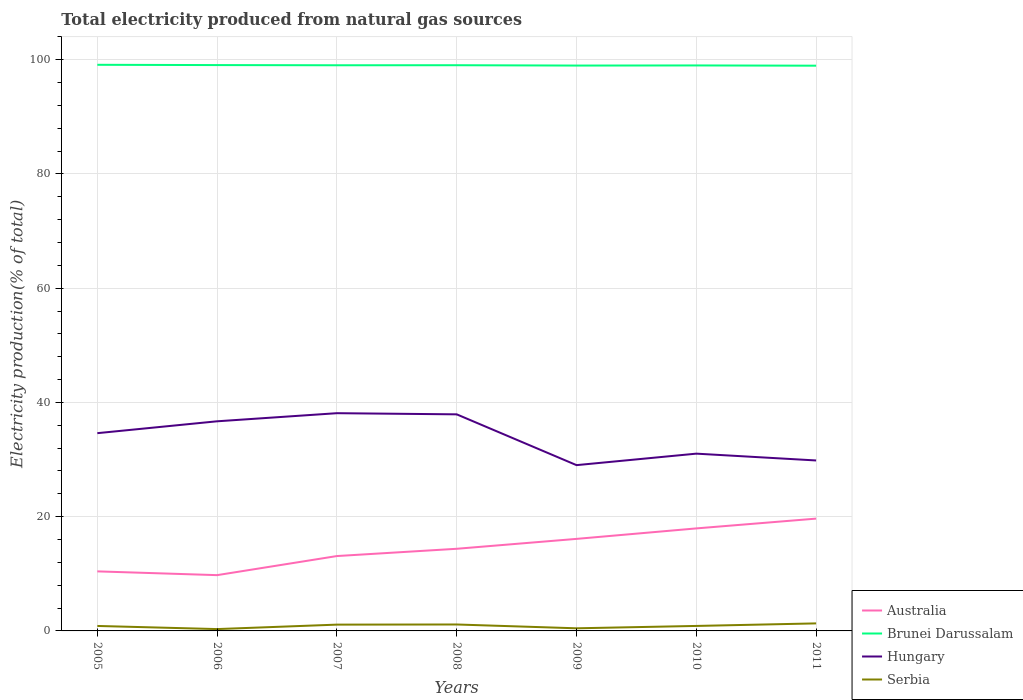How many different coloured lines are there?
Give a very brief answer. 4. Does the line corresponding to Hungary intersect with the line corresponding to Serbia?
Your answer should be very brief. No. Across all years, what is the maximum total electricity produced in Australia?
Give a very brief answer. 9.77. In which year was the total electricity produced in Serbia maximum?
Keep it short and to the point. 2006. What is the total total electricity produced in Serbia in the graph?
Give a very brief answer. -0. What is the difference between the highest and the second highest total electricity produced in Australia?
Keep it short and to the point. 9.9. How many years are there in the graph?
Offer a very short reply. 7. Are the values on the major ticks of Y-axis written in scientific E-notation?
Make the answer very short. No. Does the graph contain grids?
Keep it short and to the point. Yes. What is the title of the graph?
Keep it short and to the point. Total electricity produced from natural gas sources. What is the Electricity production(% of total) of Australia in 2005?
Provide a short and direct response. 10.42. What is the Electricity production(% of total) in Brunei Darussalam in 2005?
Make the answer very short. 99.11. What is the Electricity production(% of total) in Hungary in 2005?
Your answer should be very brief. 34.62. What is the Electricity production(% of total) of Serbia in 2005?
Keep it short and to the point. 0.87. What is the Electricity production(% of total) of Australia in 2006?
Offer a terse response. 9.77. What is the Electricity production(% of total) in Brunei Darussalam in 2006?
Your answer should be compact. 99.06. What is the Electricity production(% of total) of Hungary in 2006?
Give a very brief answer. 36.7. What is the Electricity production(% of total) of Serbia in 2006?
Your answer should be very brief. 0.32. What is the Electricity production(% of total) of Australia in 2007?
Your answer should be compact. 13.11. What is the Electricity production(% of total) of Brunei Darussalam in 2007?
Offer a very short reply. 99.03. What is the Electricity production(% of total) of Hungary in 2007?
Your answer should be compact. 38.12. What is the Electricity production(% of total) of Serbia in 2007?
Provide a short and direct response. 1.1. What is the Electricity production(% of total) of Australia in 2008?
Give a very brief answer. 14.38. What is the Electricity production(% of total) in Brunei Darussalam in 2008?
Provide a succinct answer. 99.04. What is the Electricity production(% of total) of Hungary in 2008?
Give a very brief answer. 37.92. What is the Electricity production(% of total) of Serbia in 2008?
Make the answer very short. 1.13. What is the Electricity production(% of total) of Australia in 2009?
Your response must be concise. 16.11. What is the Electricity production(% of total) of Brunei Darussalam in 2009?
Ensure brevity in your answer.  98.98. What is the Electricity production(% of total) of Hungary in 2009?
Your response must be concise. 29.02. What is the Electricity production(% of total) in Serbia in 2009?
Provide a succinct answer. 0.46. What is the Electricity production(% of total) in Australia in 2010?
Provide a short and direct response. 17.95. What is the Electricity production(% of total) in Brunei Darussalam in 2010?
Keep it short and to the point. 99. What is the Electricity production(% of total) of Hungary in 2010?
Ensure brevity in your answer.  31.03. What is the Electricity production(% of total) of Serbia in 2010?
Give a very brief answer. 0.87. What is the Electricity production(% of total) in Australia in 2011?
Keep it short and to the point. 19.66. What is the Electricity production(% of total) in Brunei Darussalam in 2011?
Provide a succinct answer. 98.95. What is the Electricity production(% of total) of Hungary in 2011?
Provide a succinct answer. 29.84. What is the Electricity production(% of total) of Serbia in 2011?
Provide a succinct answer. 1.32. Across all years, what is the maximum Electricity production(% of total) of Australia?
Give a very brief answer. 19.66. Across all years, what is the maximum Electricity production(% of total) of Brunei Darussalam?
Ensure brevity in your answer.  99.11. Across all years, what is the maximum Electricity production(% of total) of Hungary?
Your answer should be very brief. 38.12. Across all years, what is the maximum Electricity production(% of total) in Serbia?
Offer a very short reply. 1.32. Across all years, what is the minimum Electricity production(% of total) of Australia?
Make the answer very short. 9.77. Across all years, what is the minimum Electricity production(% of total) of Brunei Darussalam?
Offer a very short reply. 98.95. Across all years, what is the minimum Electricity production(% of total) in Hungary?
Provide a short and direct response. 29.02. Across all years, what is the minimum Electricity production(% of total) in Serbia?
Ensure brevity in your answer.  0.32. What is the total Electricity production(% of total) of Australia in the graph?
Provide a short and direct response. 101.4. What is the total Electricity production(% of total) in Brunei Darussalam in the graph?
Keep it short and to the point. 693.16. What is the total Electricity production(% of total) of Hungary in the graph?
Offer a very short reply. 237.26. What is the total Electricity production(% of total) in Serbia in the graph?
Your response must be concise. 6.07. What is the difference between the Electricity production(% of total) in Australia in 2005 and that in 2006?
Offer a terse response. 0.66. What is the difference between the Electricity production(% of total) in Brunei Darussalam in 2005 and that in 2006?
Keep it short and to the point. 0.05. What is the difference between the Electricity production(% of total) in Hungary in 2005 and that in 2006?
Provide a succinct answer. -2.08. What is the difference between the Electricity production(% of total) in Serbia in 2005 and that in 2006?
Offer a very short reply. 0.55. What is the difference between the Electricity production(% of total) in Australia in 2005 and that in 2007?
Ensure brevity in your answer.  -2.68. What is the difference between the Electricity production(% of total) of Brunei Darussalam in 2005 and that in 2007?
Offer a terse response. 0.08. What is the difference between the Electricity production(% of total) in Hungary in 2005 and that in 2007?
Provide a short and direct response. -3.5. What is the difference between the Electricity production(% of total) of Serbia in 2005 and that in 2007?
Keep it short and to the point. -0.23. What is the difference between the Electricity production(% of total) of Australia in 2005 and that in 2008?
Provide a succinct answer. -3.96. What is the difference between the Electricity production(% of total) in Brunei Darussalam in 2005 and that in 2008?
Ensure brevity in your answer.  0.08. What is the difference between the Electricity production(% of total) of Hungary in 2005 and that in 2008?
Offer a very short reply. -3.3. What is the difference between the Electricity production(% of total) of Serbia in 2005 and that in 2008?
Give a very brief answer. -0.26. What is the difference between the Electricity production(% of total) in Australia in 2005 and that in 2009?
Your answer should be very brief. -5.69. What is the difference between the Electricity production(% of total) in Brunei Darussalam in 2005 and that in 2009?
Your answer should be very brief. 0.14. What is the difference between the Electricity production(% of total) in Hungary in 2005 and that in 2009?
Your answer should be compact. 5.6. What is the difference between the Electricity production(% of total) of Serbia in 2005 and that in 2009?
Your answer should be very brief. 0.41. What is the difference between the Electricity production(% of total) of Australia in 2005 and that in 2010?
Give a very brief answer. -7.52. What is the difference between the Electricity production(% of total) of Brunei Darussalam in 2005 and that in 2010?
Give a very brief answer. 0.11. What is the difference between the Electricity production(% of total) of Hungary in 2005 and that in 2010?
Your answer should be very brief. 3.59. What is the difference between the Electricity production(% of total) of Serbia in 2005 and that in 2010?
Provide a succinct answer. -0. What is the difference between the Electricity production(% of total) of Australia in 2005 and that in 2011?
Give a very brief answer. -9.24. What is the difference between the Electricity production(% of total) in Brunei Darussalam in 2005 and that in 2011?
Give a very brief answer. 0.16. What is the difference between the Electricity production(% of total) of Hungary in 2005 and that in 2011?
Your response must be concise. 4.78. What is the difference between the Electricity production(% of total) in Serbia in 2005 and that in 2011?
Your answer should be compact. -0.45. What is the difference between the Electricity production(% of total) in Australia in 2006 and that in 2007?
Your answer should be very brief. -3.34. What is the difference between the Electricity production(% of total) in Brunei Darussalam in 2006 and that in 2007?
Make the answer very short. 0.03. What is the difference between the Electricity production(% of total) of Hungary in 2006 and that in 2007?
Offer a very short reply. -1.42. What is the difference between the Electricity production(% of total) of Serbia in 2006 and that in 2007?
Keep it short and to the point. -0.78. What is the difference between the Electricity production(% of total) in Australia in 2006 and that in 2008?
Offer a terse response. -4.62. What is the difference between the Electricity production(% of total) in Brunei Darussalam in 2006 and that in 2008?
Your answer should be very brief. 0.02. What is the difference between the Electricity production(% of total) of Hungary in 2006 and that in 2008?
Your answer should be compact. -1.22. What is the difference between the Electricity production(% of total) in Serbia in 2006 and that in 2008?
Make the answer very short. -0.8. What is the difference between the Electricity production(% of total) in Australia in 2006 and that in 2009?
Your response must be concise. -6.35. What is the difference between the Electricity production(% of total) of Brunei Darussalam in 2006 and that in 2009?
Your response must be concise. 0.08. What is the difference between the Electricity production(% of total) of Hungary in 2006 and that in 2009?
Your answer should be compact. 7.68. What is the difference between the Electricity production(% of total) of Serbia in 2006 and that in 2009?
Your response must be concise. -0.14. What is the difference between the Electricity production(% of total) in Australia in 2006 and that in 2010?
Offer a terse response. -8.18. What is the difference between the Electricity production(% of total) in Brunei Darussalam in 2006 and that in 2010?
Keep it short and to the point. 0.06. What is the difference between the Electricity production(% of total) of Hungary in 2006 and that in 2010?
Offer a terse response. 5.66. What is the difference between the Electricity production(% of total) in Serbia in 2006 and that in 2010?
Keep it short and to the point. -0.55. What is the difference between the Electricity production(% of total) in Australia in 2006 and that in 2011?
Provide a succinct answer. -9.9. What is the difference between the Electricity production(% of total) in Brunei Darussalam in 2006 and that in 2011?
Provide a succinct answer. 0.11. What is the difference between the Electricity production(% of total) in Hungary in 2006 and that in 2011?
Provide a succinct answer. 6.86. What is the difference between the Electricity production(% of total) in Serbia in 2006 and that in 2011?
Offer a very short reply. -0.99. What is the difference between the Electricity production(% of total) in Australia in 2007 and that in 2008?
Offer a terse response. -1.27. What is the difference between the Electricity production(% of total) in Brunei Darussalam in 2007 and that in 2008?
Your answer should be very brief. -0.01. What is the difference between the Electricity production(% of total) of Hungary in 2007 and that in 2008?
Your answer should be very brief. 0.2. What is the difference between the Electricity production(% of total) of Serbia in 2007 and that in 2008?
Provide a succinct answer. -0.02. What is the difference between the Electricity production(% of total) in Australia in 2007 and that in 2009?
Your answer should be very brief. -3.01. What is the difference between the Electricity production(% of total) of Brunei Darussalam in 2007 and that in 2009?
Your answer should be very brief. 0.05. What is the difference between the Electricity production(% of total) in Hungary in 2007 and that in 2009?
Keep it short and to the point. 9.09. What is the difference between the Electricity production(% of total) of Serbia in 2007 and that in 2009?
Your answer should be very brief. 0.64. What is the difference between the Electricity production(% of total) in Australia in 2007 and that in 2010?
Make the answer very short. -4.84. What is the difference between the Electricity production(% of total) in Brunei Darussalam in 2007 and that in 2010?
Offer a very short reply. 0.03. What is the difference between the Electricity production(% of total) in Hungary in 2007 and that in 2010?
Offer a terse response. 7.08. What is the difference between the Electricity production(% of total) in Serbia in 2007 and that in 2010?
Provide a short and direct response. 0.23. What is the difference between the Electricity production(% of total) of Australia in 2007 and that in 2011?
Offer a terse response. -6.55. What is the difference between the Electricity production(% of total) of Brunei Darussalam in 2007 and that in 2011?
Offer a terse response. 0.07. What is the difference between the Electricity production(% of total) of Hungary in 2007 and that in 2011?
Offer a terse response. 8.28. What is the difference between the Electricity production(% of total) in Serbia in 2007 and that in 2011?
Provide a succinct answer. -0.21. What is the difference between the Electricity production(% of total) in Australia in 2008 and that in 2009?
Provide a succinct answer. -1.73. What is the difference between the Electricity production(% of total) in Brunei Darussalam in 2008 and that in 2009?
Make the answer very short. 0.06. What is the difference between the Electricity production(% of total) of Hungary in 2008 and that in 2009?
Your response must be concise. 8.89. What is the difference between the Electricity production(% of total) of Serbia in 2008 and that in 2009?
Make the answer very short. 0.67. What is the difference between the Electricity production(% of total) in Australia in 2008 and that in 2010?
Provide a succinct answer. -3.57. What is the difference between the Electricity production(% of total) in Brunei Darussalam in 2008 and that in 2010?
Provide a short and direct response. 0.04. What is the difference between the Electricity production(% of total) in Hungary in 2008 and that in 2010?
Ensure brevity in your answer.  6.88. What is the difference between the Electricity production(% of total) in Serbia in 2008 and that in 2010?
Give a very brief answer. 0.25. What is the difference between the Electricity production(% of total) in Australia in 2008 and that in 2011?
Give a very brief answer. -5.28. What is the difference between the Electricity production(% of total) in Brunei Darussalam in 2008 and that in 2011?
Your answer should be compact. 0.08. What is the difference between the Electricity production(% of total) of Hungary in 2008 and that in 2011?
Offer a very short reply. 8.07. What is the difference between the Electricity production(% of total) in Serbia in 2008 and that in 2011?
Provide a succinct answer. -0.19. What is the difference between the Electricity production(% of total) of Australia in 2009 and that in 2010?
Provide a short and direct response. -1.83. What is the difference between the Electricity production(% of total) of Brunei Darussalam in 2009 and that in 2010?
Offer a terse response. -0.02. What is the difference between the Electricity production(% of total) of Hungary in 2009 and that in 2010?
Make the answer very short. -2.01. What is the difference between the Electricity production(% of total) in Serbia in 2009 and that in 2010?
Make the answer very short. -0.42. What is the difference between the Electricity production(% of total) of Australia in 2009 and that in 2011?
Your answer should be compact. -3.55. What is the difference between the Electricity production(% of total) in Brunei Darussalam in 2009 and that in 2011?
Keep it short and to the point. 0.02. What is the difference between the Electricity production(% of total) in Hungary in 2009 and that in 2011?
Your response must be concise. -0.82. What is the difference between the Electricity production(% of total) in Serbia in 2009 and that in 2011?
Offer a very short reply. -0.86. What is the difference between the Electricity production(% of total) of Australia in 2010 and that in 2011?
Offer a terse response. -1.71. What is the difference between the Electricity production(% of total) in Brunei Darussalam in 2010 and that in 2011?
Your answer should be compact. 0.04. What is the difference between the Electricity production(% of total) of Hungary in 2010 and that in 2011?
Provide a short and direct response. 1.19. What is the difference between the Electricity production(% of total) of Serbia in 2010 and that in 2011?
Provide a short and direct response. -0.44. What is the difference between the Electricity production(% of total) in Australia in 2005 and the Electricity production(% of total) in Brunei Darussalam in 2006?
Ensure brevity in your answer.  -88.64. What is the difference between the Electricity production(% of total) in Australia in 2005 and the Electricity production(% of total) in Hungary in 2006?
Your answer should be compact. -26.28. What is the difference between the Electricity production(% of total) in Australia in 2005 and the Electricity production(% of total) in Serbia in 2006?
Offer a very short reply. 10.1. What is the difference between the Electricity production(% of total) of Brunei Darussalam in 2005 and the Electricity production(% of total) of Hungary in 2006?
Your answer should be very brief. 62.41. What is the difference between the Electricity production(% of total) in Brunei Darussalam in 2005 and the Electricity production(% of total) in Serbia in 2006?
Your response must be concise. 98.79. What is the difference between the Electricity production(% of total) of Hungary in 2005 and the Electricity production(% of total) of Serbia in 2006?
Provide a succinct answer. 34.3. What is the difference between the Electricity production(% of total) of Australia in 2005 and the Electricity production(% of total) of Brunei Darussalam in 2007?
Your response must be concise. -88.6. What is the difference between the Electricity production(% of total) of Australia in 2005 and the Electricity production(% of total) of Hungary in 2007?
Provide a short and direct response. -27.69. What is the difference between the Electricity production(% of total) in Australia in 2005 and the Electricity production(% of total) in Serbia in 2007?
Keep it short and to the point. 9.32. What is the difference between the Electricity production(% of total) of Brunei Darussalam in 2005 and the Electricity production(% of total) of Hungary in 2007?
Ensure brevity in your answer.  60.99. What is the difference between the Electricity production(% of total) in Brunei Darussalam in 2005 and the Electricity production(% of total) in Serbia in 2007?
Your answer should be compact. 98.01. What is the difference between the Electricity production(% of total) of Hungary in 2005 and the Electricity production(% of total) of Serbia in 2007?
Your answer should be compact. 33.52. What is the difference between the Electricity production(% of total) in Australia in 2005 and the Electricity production(% of total) in Brunei Darussalam in 2008?
Provide a short and direct response. -88.61. What is the difference between the Electricity production(% of total) of Australia in 2005 and the Electricity production(% of total) of Hungary in 2008?
Offer a very short reply. -27.49. What is the difference between the Electricity production(% of total) in Australia in 2005 and the Electricity production(% of total) in Serbia in 2008?
Ensure brevity in your answer.  9.3. What is the difference between the Electricity production(% of total) in Brunei Darussalam in 2005 and the Electricity production(% of total) in Hungary in 2008?
Provide a short and direct response. 61.2. What is the difference between the Electricity production(% of total) of Brunei Darussalam in 2005 and the Electricity production(% of total) of Serbia in 2008?
Make the answer very short. 97.98. What is the difference between the Electricity production(% of total) in Hungary in 2005 and the Electricity production(% of total) in Serbia in 2008?
Provide a short and direct response. 33.49. What is the difference between the Electricity production(% of total) of Australia in 2005 and the Electricity production(% of total) of Brunei Darussalam in 2009?
Your answer should be very brief. -88.55. What is the difference between the Electricity production(% of total) of Australia in 2005 and the Electricity production(% of total) of Hungary in 2009?
Provide a succinct answer. -18.6. What is the difference between the Electricity production(% of total) in Australia in 2005 and the Electricity production(% of total) in Serbia in 2009?
Keep it short and to the point. 9.97. What is the difference between the Electricity production(% of total) in Brunei Darussalam in 2005 and the Electricity production(% of total) in Hungary in 2009?
Give a very brief answer. 70.09. What is the difference between the Electricity production(% of total) in Brunei Darussalam in 2005 and the Electricity production(% of total) in Serbia in 2009?
Keep it short and to the point. 98.65. What is the difference between the Electricity production(% of total) in Hungary in 2005 and the Electricity production(% of total) in Serbia in 2009?
Make the answer very short. 34.16. What is the difference between the Electricity production(% of total) in Australia in 2005 and the Electricity production(% of total) in Brunei Darussalam in 2010?
Your answer should be very brief. -88.57. What is the difference between the Electricity production(% of total) of Australia in 2005 and the Electricity production(% of total) of Hungary in 2010?
Provide a short and direct response. -20.61. What is the difference between the Electricity production(% of total) in Australia in 2005 and the Electricity production(% of total) in Serbia in 2010?
Offer a terse response. 9.55. What is the difference between the Electricity production(% of total) in Brunei Darussalam in 2005 and the Electricity production(% of total) in Hungary in 2010?
Ensure brevity in your answer.  68.08. What is the difference between the Electricity production(% of total) of Brunei Darussalam in 2005 and the Electricity production(% of total) of Serbia in 2010?
Keep it short and to the point. 98.24. What is the difference between the Electricity production(% of total) of Hungary in 2005 and the Electricity production(% of total) of Serbia in 2010?
Your response must be concise. 33.75. What is the difference between the Electricity production(% of total) in Australia in 2005 and the Electricity production(% of total) in Brunei Darussalam in 2011?
Make the answer very short. -88.53. What is the difference between the Electricity production(% of total) in Australia in 2005 and the Electricity production(% of total) in Hungary in 2011?
Keep it short and to the point. -19.42. What is the difference between the Electricity production(% of total) of Australia in 2005 and the Electricity production(% of total) of Serbia in 2011?
Your answer should be very brief. 9.11. What is the difference between the Electricity production(% of total) in Brunei Darussalam in 2005 and the Electricity production(% of total) in Hungary in 2011?
Give a very brief answer. 69.27. What is the difference between the Electricity production(% of total) in Brunei Darussalam in 2005 and the Electricity production(% of total) in Serbia in 2011?
Give a very brief answer. 97.79. What is the difference between the Electricity production(% of total) of Hungary in 2005 and the Electricity production(% of total) of Serbia in 2011?
Offer a very short reply. 33.3. What is the difference between the Electricity production(% of total) in Australia in 2006 and the Electricity production(% of total) in Brunei Darussalam in 2007?
Give a very brief answer. -89.26. What is the difference between the Electricity production(% of total) in Australia in 2006 and the Electricity production(% of total) in Hungary in 2007?
Provide a short and direct response. -28.35. What is the difference between the Electricity production(% of total) in Australia in 2006 and the Electricity production(% of total) in Serbia in 2007?
Provide a short and direct response. 8.66. What is the difference between the Electricity production(% of total) in Brunei Darussalam in 2006 and the Electricity production(% of total) in Hungary in 2007?
Make the answer very short. 60.94. What is the difference between the Electricity production(% of total) of Brunei Darussalam in 2006 and the Electricity production(% of total) of Serbia in 2007?
Make the answer very short. 97.96. What is the difference between the Electricity production(% of total) of Hungary in 2006 and the Electricity production(% of total) of Serbia in 2007?
Your response must be concise. 35.6. What is the difference between the Electricity production(% of total) in Australia in 2006 and the Electricity production(% of total) in Brunei Darussalam in 2008?
Your response must be concise. -89.27. What is the difference between the Electricity production(% of total) of Australia in 2006 and the Electricity production(% of total) of Hungary in 2008?
Your response must be concise. -28.15. What is the difference between the Electricity production(% of total) of Australia in 2006 and the Electricity production(% of total) of Serbia in 2008?
Ensure brevity in your answer.  8.64. What is the difference between the Electricity production(% of total) of Brunei Darussalam in 2006 and the Electricity production(% of total) of Hungary in 2008?
Provide a succinct answer. 61.14. What is the difference between the Electricity production(% of total) of Brunei Darussalam in 2006 and the Electricity production(% of total) of Serbia in 2008?
Give a very brief answer. 97.93. What is the difference between the Electricity production(% of total) in Hungary in 2006 and the Electricity production(% of total) in Serbia in 2008?
Make the answer very short. 35.57. What is the difference between the Electricity production(% of total) of Australia in 2006 and the Electricity production(% of total) of Brunei Darussalam in 2009?
Ensure brevity in your answer.  -89.21. What is the difference between the Electricity production(% of total) in Australia in 2006 and the Electricity production(% of total) in Hungary in 2009?
Make the answer very short. -19.26. What is the difference between the Electricity production(% of total) of Australia in 2006 and the Electricity production(% of total) of Serbia in 2009?
Provide a short and direct response. 9.31. What is the difference between the Electricity production(% of total) in Brunei Darussalam in 2006 and the Electricity production(% of total) in Hungary in 2009?
Make the answer very short. 70.04. What is the difference between the Electricity production(% of total) in Brunei Darussalam in 2006 and the Electricity production(% of total) in Serbia in 2009?
Keep it short and to the point. 98.6. What is the difference between the Electricity production(% of total) in Hungary in 2006 and the Electricity production(% of total) in Serbia in 2009?
Give a very brief answer. 36.24. What is the difference between the Electricity production(% of total) in Australia in 2006 and the Electricity production(% of total) in Brunei Darussalam in 2010?
Provide a short and direct response. -89.23. What is the difference between the Electricity production(% of total) of Australia in 2006 and the Electricity production(% of total) of Hungary in 2010?
Your answer should be compact. -21.27. What is the difference between the Electricity production(% of total) of Australia in 2006 and the Electricity production(% of total) of Serbia in 2010?
Provide a short and direct response. 8.89. What is the difference between the Electricity production(% of total) in Brunei Darussalam in 2006 and the Electricity production(% of total) in Hungary in 2010?
Your answer should be very brief. 68.03. What is the difference between the Electricity production(% of total) of Brunei Darussalam in 2006 and the Electricity production(% of total) of Serbia in 2010?
Offer a terse response. 98.19. What is the difference between the Electricity production(% of total) in Hungary in 2006 and the Electricity production(% of total) in Serbia in 2010?
Provide a short and direct response. 35.83. What is the difference between the Electricity production(% of total) in Australia in 2006 and the Electricity production(% of total) in Brunei Darussalam in 2011?
Give a very brief answer. -89.19. What is the difference between the Electricity production(% of total) in Australia in 2006 and the Electricity production(% of total) in Hungary in 2011?
Provide a short and direct response. -20.08. What is the difference between the Electricity production(% of total) of Australia in 2006 and the Electricity production(% of total) of Serbia in 2011?
Give a very brief answer. 8.45. What is the difference between the Electricity production(% of total) of Brunei Darussalam in 2006 and the Electricity production(% of total) of Hungary in 2011?
Offer a terse response. 69.22. What is the difference between the Electricity production(% of total) of Brunei Darussalam in 2006 and the Electricity production(% of total) of Serbia in 2011?
Give a very brief answer. 97.74. What is the difference between the Electricity production(% of total) of Hungary in 2006 and the Electricity production(% of total) of Serbia in 2011?
Your answer should be compact. 35.38. What is the difference between the Electricity production(% of total) of Australia in 2007 and the Electricity production(% of total) of Brunei Darussalam in 2008?
Your answer should be compact. -85.93. What is the difference between the Electricity production(% of total) of Australia in 2007 and the Electricity production(% of total) of Hungary in 2008?
Ensure brevity in your answer.  -24.81. What is the difference between the Electricity production(% of total) in Australia in 2007 and the Electricity production(% of total) in Serbia in 2008?
Provide a short and direct response. 11.98. What is the difference between the Electricity production(% of total) in Brunei Darussalam in 2007 and the Electricity production(% of total) in Hungary in 2008?
Make the answer very short. 61.11. What is the difference between the Electricity production(% of total) in Brunei Darussalam in 2007 and the Electricity production(% of total) in Serbia in 2008?
Offer a very short reply. 97.9. What is the difference between the Electricity production(% of total) in Hungary in 2007 and the Electricity production(% of total) in Serbia in 2008?
Offer a terse response. 36.99. What is the difference between the Electricity production(% of total) of Australia in 2007 and the Electricity production(% of total) of Brunei Darussalam in 2009?
Your answer should be very brief. -85.87. What is the difference between the Electricity production(% of total) of Australia in 2007 and the Electricity production(% of total) of Hungary in 2009?
Provide a short and direct response. -15.92. What is the difference between the Electricity production(% of total) in Australia in 2007 and the Electricity production(% of total) in Serbia in 2009?
Provide a succinct answer. 12.65. What is the difference between the Electricity production(% of total) in Brunei Darussalam in 2007 and the Electricity production(% of total) in Hungary in 2009?
Offer a very short reply. 70. What is the difference between the Electricity production(% of total) of Brunei Darussalam in 2007 and the Electricity production(% of total) of Serbia in 2009?
Provide a short and direct response. 98.57. What is the difference between the Electricity production(% of total) in Hungary in 2007 and the Electricity production(% of total) in Serbia in 2009?
Give a very brief answer. 37.66. What is the difference between the Electricity production(% of total) of Australia in 2007 and the Electricity production(% of total) of Brunei Darussalam in 2010?
Your response must be concise. -85.89. What is the difference between the Electricity production(% of total) of Australia in 2007 and the Electricity production(% of total) of Hungary in 2010?
Ensure brevity in your answer.  -17.93. What is the difference between the Electricity production(% of total) of Australia in 2007 and the Electricity production(% of total) of Serbia in 2010?
Ensure brevity in your answer.  12.23. What is the difference between the Electricity production(% of total) of Brunei Darussalam in 2007 and the Electricity production(% of total) of Hungary in 2010?
Offer a terse response. 67.99. What is the difference between the Electricity production(% of total) in Brunei Darussalam in 2007 and the Electricity production(% of total) in Serbia in 2010?
Give a very brief answer. 98.15. What is the difference between the Electricity production(% of total) of Hungary in 2007 and the Electricity production(% of total) of Serbia in 2010?
Keep it short and to the point. 37.24. What is the difference between the Electricity production(% of total) of Australia in 2007 and the Electricity production(% of total) of Brunei Darussalam in 2011?
Offer a terse response. -85.85. What is the difference between the Electricity production(% of total) of Australia in 2007 and the Electricity production(% of total) of Hungary in 2011?
Your response must be concise. -16.73. What is the difference between the Electricity production(% of total) in Australia in 2007 and the Electricity production(% of total) in Serbia in 2011?
Provide a succinct answer. 11.79. What is the difference between the Electricity production(% of total) in Brunei Darussalam in 2007 and the Electricity production(% of total) in Hungary in 2011?
Your answer should be compact. 69.19. What is the difference between the Electricity production(% of total) in Brunei Darussalam in 2007 and the Electricity production(% of total) in Serbia in 2011?
Your response must be concise. 97.71. What is the difference between the Electricity production(% of total) in Hungary in 2007 and the Electricity production(% of total) in Serbia in 2011?
Offer a very short reply. 36.8. What is the difference between the Electricity production(% of total) in Australia in 2008 and the Electricity production(% of total) in Brunei Darussalam in 2009?
Your response must be concise. -84.6. What is the difference between the Electricity production(% of total) of Australia in 2008 and the Electricity production(% of total) of Hungary in 2009?
Keep it short and to the point. -14.64. What is the difference between the Electricity production(% of total) of Australia in 2008 and the Electricity production(% of total) of Serbia in 2009?
Make the answer very short. 13.92. What is the difference between the Electricity production(% of total) in Brunei Darussalam in 2008 and the Electricity production(% of total) in Hungary in 2009?
Your answer should be very brief. 70.01. What is the difference between the Electricity production(% of total) in Brunei Darussalam in 2008 and the Electricity production(% of total) in Serbia in 2009?
Keep it short and to the point. 98.58. What is the difference between the Electricity production(% of total) of Hungary in 2008 and the Electricity production(% of total) of Serbia in 2009?
Offer a terse response. 37.46. What is the difference between the Electricity production(% of total) in Australia in 2008 and the Electricity production(% of total) in Brunei Darussalam in 2010?
Offer a terse response. -84.62. What is the difference between the Electricity production(% of total) in Australia in 2008 and the Electricity production(% of total) in Hungary in 2010?
Provide a short and direct response. -16.65. What is the difference between the Electricity production(% of total) in Australia in 2008 and the Electricity production(% of total) in Serbia in 2010?
Provide a succinct answer. 13.51. What is the difference between the Electricity production(% of total) of Brunei Darussalam in 2008 and the Electricity production(% of total) of Hungary in 2010?
Your answer should be very brief. 68. What is the difference between the Electricity production(% of total) of Brunei Darussalam in 2008 and the Electricity production(% of total) of Serbia in 2010?
Ensure brevity in your answer.  98.16. What is the difference between the Electricity production(% of total) of Hungary in 2008 and the Electricity production(% of total) of Serbia in 2010?
Provide a short and direct response. 37.04. What is the difference between the Electricity production(% of total) of Australia in 2008 and the Electricity production(% of total) of Brunei Darussalam in 2011?
Keep it short and to the point. -84.57. What is the difference between the Electricity production(% of total) in Australia in 2008 and the Electricity production(% of total) in Hungary in 2011?
Offer a terse response. -15.46. What is the difference between the Electricity production(% of total) in Australia in 2008 and the Electricity production(% of total) in Serbia in 2011?
Ensure brevity in your answer.  13.06. What is the difference between the Electricity production(% of total) of Brunei Darussalam in 2008 and the Electricity production(% of total) of Hungary in 2011?
Give a very brief answer. 69.19. What is the difference between the Electricity production(% of total) in Brunei Darussalam in 2008 and the Electricity production(% of total) in Serbia in 2011?
Ensure brevity in your answer.  97.72. What is the difference between the Electricity production(% of total) in Hungary in 2008 and the Electricity production(% of total) in Serbia in 2011?
Your response must be concise. 36.6. What is the difference between the Electricity production(% of total) of Australia in 2009 and the Electricity production(% of total) of Brunei Darussalam in 2010?
Keep it short and to the point. -82.88. What is the difference between the Electricity production(% of total) of Australia in 2009 and the Electricity production(% of total) of Hungary in 2010?
Provide a short and direct response. -14.92. What is the difference between the Electricity production(% of total) of Australia in 2009 and the Electricity production(% of total) of Serbia in 2010?
Your answer should be very brief. 15.24. What is the difference between the Electricity production(% of total) of Brunei Darussalam in 2009 and the Electricity production(% of total) of Hungary in 2010?
Provide a short and direct response. 67.94. What is the difference between the Electricity production(% of total) in Brunei Darussalam in 2009 and the Electricity production(% of total) in Serbia in 2010?
Your response must be concise. 98.1. What is the difference between the Electricity production(% of total) in Hungary in 2009 and the Electricity production(% of total) in Serbia in 2010?
Offer a very short reply. 28.15. What is the difference between the Electricity production(% of total) in Australia in 2009 and the Electricity production(% of total) in Brunei Darussalam in 2011?
Your answer should be compact. -82.84. What is the difference between the Electricity production(% of total) in Australia in 2009 and the Electricity production(% of total) in Hungary in 2011?
Provide a succinct answer. -13.73. What is the difference between the Electricity production(% of total) in Australia in 2009 and the Electricity production(% of total) in Serbia in 2011?
Keep it short and to the point. 14.8. What is the difference between the Electricity production(% of total) in Brunei Darussalam in 2009 and the Electricity production(% of total) in Hungary in 2011?
Offer a very short reply. 69.13. What is the difference between the Electricity production(% of total) in Brunei Darussalam in 2009 and the Electricity production(% of total) in Serbia in 2011?
Give a very brief answer. 97.66. What is the difference between the Electricity production(% of total) of Hungary in 2009 and the Electricity production(% of total) of Serbia in 2011?
Your answer should be very brief. 27.71. What is the difference between the Electricity production(% of total) of Australia in 2010 and the Electricity production(% of total) of Brunei Darussalam in 2011?
Offer a terse response. -81.01. What is the difference between the Electricity production(% of total) of Australia in 2010 and the Electricity production(% of total) of Hungary in 2011?
Your answer should be very brief. -11.89. What is the difference between the Electricity production(% of total) in Australia in 2010 and the Electricity production(% of total) in Serbia in 2011?
Offer a terse response. 16.63. What is the difference between the Electricity production(% of total) of Brunei Darussalam in 2010 and the Electricity production(% of total) of Hungary in 2011?
Make the answer very short. 69.16. What is the difference between the Electricity production(% of total) in Brunei Darussalam in 2010 and the Electricity production(% of total) in Serbia in 2011?
Keep it short and to the point. 97.68. What is the difference between the Electricity production(% of total) of Hungary in 2010 and the Electricity production(% of total) of Serbia in 2011?
Offer a very short reply. 29.72. What is the average Electricity production(% of total) in Australia per year?
Your answer should be very brief. 14.49. What is the average Electricity production(% of total) in Brunei Darussalam per year?
Your answer should be compact. 99.02. What is the average Electricity production(% of total) of Hungary per year?
Keep it short and to the point. 33.89. What is the average Electricity production(% of total) in Serbia per year?
Give a very brief answer. 0.87. In the year 2005, what is the difference between the Electricity production(% of total) in Australia and Electricity production(% of total) in Brunei Darussalam?
Your answer should be very brief. -88.69. In the year 2005, what is the difference between the Electricity production(% of total) of Australia and Electricity production(% of total) of Hungary?
Offer a terse response. -24.2. In the year 2005, what is the difference between the Electricity production(% of total) in Australia and Electricity production(% of total) in Serbia?
Your answer should be compact. 9.55. In the year 2005, what is the difference between the Electricity production(% of total) of Brunei Darussalam and Electricity production(% of total) of Hungary?
Your response must be concise. 64.49. In the year 2005, what is the difference between the Electricity production(% of total) of Brunei Darussalam and Electricity production(% of total) of Serbia?
Your answer should be very brief. 98.24. In the year 2005, what is the difference between the Electricity production(% of total) of Hungary and Electricity production(% of total) of Serbia?
Provide a succinct answer. 33.75. In the year 2006, what is the difference between the Electricity production(% of total) in Australia and Electricity production(% of total) in Brunei Darussalam?
Give a very brief answer. -89.29. In the year 2006, what is the difference between the Electricity production(% of total) of Australia and Electricity production(% of total) of Hungary?
Ensure brevity in your answer.  -26.93. In the year 2006, what is the difference between the Electricity production(% of total) in Australia and Electricity production(% of total) in Serbia?
Your answer should be compact. 9.44. In the year 2006, what is the difference between the Electricity production(% of total) in Brunei Darussalam and Electricity production(% of total) in Hungary?
Keep it short and to the point. 62.36. In the year 2006, what is the difference between the Electricity production(% of total) of Brunei Darussalam and Electricity production(% of total) of Serbia?
Offer a terse response. 98.74. In the year 2006, what is the difference between the Electricity production(% of total) of Hungary and Electricity production(% of total) of Serbia?
Provide a succinct answer. 36.38. In the year 2007, what is the difference between the Electricity production(% of total) of Australia and Electricity production(% of total) of Brunei Darussalam?
Offer a terse response. -85.92. In the year 2007, what is the difference between the Electricity production(% of total) in Australia and Electricity production(% of total) in Hungary?
Your response must be concise. -25.01. In the year 2007, what is the difference between the Electricity production(% of total) of Australia and Electricity production(% of total) of Serbia?
Offer a terse response. 12.01. In the year 2007, what is the difference between the Electricity production(% of total) of Brunei Darussalam and Electricity production(% of total) of Hungary?
Your response must be concise. 60.91. In the year 2007, what is the difference between the Electricity production(% of total) of Brunei Darussalam and Electricity production(% of total) of Serbia?
Make the answer very short. 97.93. In the year 2007, what is the difference between the Electricity production(% of total) of Hungary and Electricity production(% of total) of Serbia?
Offer a terse response. 37.02. In the year 2008, what is the difference between the Electricity production(% of total) of Australia and Electricity production(% of total) of Brunei Darussalam?
Ensure brevity in your answer.  -84.66. In the year 2008, what is the difference between the Electricity production(% of total) of Australia and Electricity production(% of total) of Hungary?
Provide a succinct answer. -23.54. In the year 2008, what is the difference between the Electricity production(% of total) of Australia and Electricity production(% of total) of Serbia?
Offer a very short reply. 13.25. In the year 2008, what is the difference between the Electricity production(% of total) in Brunei Darussalam and Electricity production(% of total) in Hungary?
Offer a terse response. 61.12. In the year 2008, what is the difference between the Electricity production(% of total) in Brunei Darussalam and Electricity production(% of total) in Serbia?
Your response must be concise. 97.91. In the year 2008, what is the difference between the Electricity production(% of total) in Hungary and Electricity production(% of total) in Serbia?
Your response must be concise. 36.79. In the year 2009, what is the difference between the Electricity production(% of total) in Australia and Electricity production(% of total) in Brunei Darussalam?
Your answer should be compact. -82.86. In the year 2009, what is the difference between the Electricity production(% of total) of Australia and Electricity production(% of total) of Hungary?
Ensure brevity in your answer.  -12.91. In the year 2009, what is the difference between the Electricity production(% of total) of Australia and Electricity production(% of total) of Serbia?
Your response must be concise. 15.65. In the year 2009, what is the difference between the Electricity production(% of total) in Brunei Darussalam and Electricity production(% of total) in Hungary?
Your answer should be very brief. 69.95. In the year 2009, what is the difference between the Electricity production(% of total) in Brunei Darussalam and Electricity production(% of total) in Serbia?
Your response must be concise. 98.52. In the year 2009, what is the difference between the Electricity production(% of total) of Hungary and Electricity production(% of total) of Serbia?
Ensure brevity in your answer.  28.57. In the year 2010, what is the difference between the Electricity production(% of total) in Australia and Electricity production(% of total) in Brunei Darussalam?
Your answer should be compact. -81.05. In the year 2010, what is the difference between the Electricity production(% of total) in Australia and Electricity production(% of total) in Hungary?
Make the answer very short. -13.09. In the year 2010, what is the difference between the Electricity production(% of total) of Australia and Electricity production(% of total) of Serbia?
Your answer should be very brief. 17.07. In the year 2010, what is the difference between the Electricity production(% of total) in Brunei Darussalam and Electricity production(% of total) in Hungary?
Your answer should be compact. 67.96. In the year 2010, what is the difference between the Electricity production(% of total) in Brunei Darussalam and Electricity production(% of total) in Serbia?
Offer a terse response. 98.12. In the year 2010, what is the difference between the Electricity production(% of total) of Hungary and Electricity production(% of total) of Serbia?
Give a very brief answer. 30.16. In the year 2011, what is the difference between the Electricity production(% of total) in Australia and Electricity production(% of total) in Brunei Darussalam?
Make the answer very short. -79.29. In the year 2011, what is the difference between the Electricity production(% of total) in Australia and Electricity production(% of total) in Hungary?
Provide a succinct answer. -10.18. In the year 2011, what is the difference between the Electricity production(% of total) of Australia and Electricity production(% of total) of Serbia?
Give a very brief answer. 18.34. In the year 2011, what is the difference between the Electricity production(% of total) in Brunei Darussalam and Electricity production(% of total) in Hungary?
Ensure brevity in your answer.  69.11. In the year 2011, what is the difference between the Electricity production(% of total) of Brunei Darussalam and Electricity production(% of total) of Serbia?
Your answer should be very brief. 97.64. In the year 2011, what is the difference between the Electricity production(% of total) in Hungary and Electricity production(% of total) in Serbia?
Make the answer very short. 28.52. What is the ratio of the Electricity production(% of total) of Australia in 2005 to that in 2006?
Provide a short and direct response. 1.07. What is the ratio of the Electricity production(% of total) of Brunei Darussalam in 2005 to that in 2006?
Ensure brevity in your answer.  1. What is the ratio of the Electricity production(% of total) in Hungary in 2005 to that in 2006?
Provide a succinct answer. 0.94. What is the ratio of the Electricity production(% of total) of Serbia in 2005 to that in 2006?
Offer a terse response. 2.69. What is the ratio of the Electricity production(% of total) in Australia in 2005 to that in 2007?
Offer a terse response. 0.8. What is the ratio of the Electricity production(% of total) of Hungary in 2005 to that in 2007?
Your response must be concise. 0.91. What is the ratio of the Electricity production(% of total) of Serbia in 2005 to that in 2007?
Provide a succinct answer. 0.79. What is the ratio of the Electricity production(% of total) of Australia in 2005 to that in 2008?
Offer a very short reply. 0.72. What is the ratio of the Electricity production(% of total) in Hungary in 2005 to that in 2008?
Ensure brevity in your answer.  0.91. What is the ratio of the Electricity production(% of total) in Serbia in 2005 to that in 2008?
Keep it short and to the point. 0.77. What is the ratio of the Electricity production(% of total) in Australia in 2005 to that in 2009?
Provide a succinct answer. 0.65. What is the ratio of the Electricity production(% of total) of Hungary in 2005 to that in 2009?
Your answer should be very brief. 1.19. What is the ratio of the Electricity production(% of total) in Serbia in 2005 to that in 2009?
Your answer should be very brief. 1.89. What is the ratio of the Electricity production(% of total) of Australia in 2005 to that in 2010?
Your answer should be very brief. 0.58. What is the ratio of the Electricity production(% of total) in Brunei Darussalam in 2005 to that in 2010?
Provide a short and direct response. 1. What is the ratio of the Electricity production(% of total) of Hungary in 2005 to that in 2010?
Give a very brief answer. 1.12. What is the ratio of the Electricity production(% of total) of Serbia in 2005 to that in 2010?
Keep it short and to the point. 0.99. What is the ratio of the Electricity production(% of total) in Australia in 2005 to that in 2011?
Provide a short and direct response. 0.53. What is the ratio of the Electricity production(% of total) of Hungary in 2005 to that in 2011?
Provide a short and direct response. 1.16. What is the ratio of the Electricity production(% of total) in Serbia in 2005 to that in 2011?
Keep it short and to the point. 0.66. What is the ratio of the Electricity production(% of total) of Australia in 2006 to that in 2007?
Your answer should be very brief. 0.74. What is the ratio of the Electricity production(% of total) of Brunei Darussalam in 2006 to that in 2007?
Offer a very short reply. 1. What is the ratio of the Electricity production(% of total) of Hungary in 2006 to that in 2007?
Your answer should be very brief. 0.96. What is the ratio of the Electricity production(% of total) in Serbia in 2006 to that in 2007?
Your answer should be very brief. 0.29. What is the ratio of the Electricity production(% of total) in Australia in 2006 to that in 2008?
Provide a succinct answer. 0.68. What is the ratio of the Electricity production(% of total) in Brunei Darussalam in 2006 to that in 2008?
Your response must be concise. 1. What is the ratio of the Electricity production(% of total) in Hungary in 2006 to that in 2008?
Provide a succinct answer. 0.97. What is the ratio of the Electricity production(% of total) of Serbia in 2006 to that in 2008?
Keep it short and to the point. 0.29. What is the ratio of the Electricity production(% of total) in Australia in 2006 to that in 2009?
Make the answer very short. 0.61. What is the ratio of the Electricity production(% of total) in Hungary in 2006 to that in 2009?
Give a very brief answer. 1.26. What is the ratio of the Electricity production(% of total) in Serbia in 2006 to that in 2009?
Offer a terse response. 0.71. What is the ratio of the Electricity production(% of total) in Australia in 2006 to that in 2010?
Offer a terse response. 0.54. What is the ratio of the Electricity production(% of total) in Hungary in 2006 to that in 2010?
Your answer should be very brief. 1.18. What is the ratio of the Electricity production(% of total) of Serbia in 2006 to that in 2010?
Ensure brevity in your answer.  0.37. What is the ratio of the Electricity production(% of total) of Australia in 2006 to that in 2011?
Give a very brief answer. 0.5. What is the ratio of the Electricity production(% of total) in Hungary in 2006 to that in 2011?
Provide a short and direct response. 1.23. What is the ratio of the Electricity production(% of total) in Serbia in 2006 to that in 2011?
Ensure brevity in your answer.  0.25. What is the ratio of the Electricity production(% of total) of Australia in 2007 to that in 2008?
Your answer should be very brief. 0.91. What is the ratio of the Electricity production(% of total) in Serbia in 2007 to that in 2008?
Provide a short and direct response. 0.98. What is the ratio of the Electricity production(% of total) of Australia in 2007 to that in 2009?
Your response must be concise. 0.81. What is the ratio of the Electricity production(% of total) of Hungary in 2007 to that in 2009?
Provide a short and direct response. 1.31. What is the ratio of the Electricity production(% of total) in Serbia in 2007 to that in 2009?
Your answer should be very brief. 2.4. What is the ratio of the Electricity production(% of total) of Australia in 2007 to that in 2010?
Provide a short and direct response. 0.73. What is the ratio of the Electricity production(% of total) in Brunei Darussalam in 2007 to that in 2010?
Your answer should be compact. 1. What is the ratio of the Electricity production(% of total) of Hungary in 2007 to that in 2010?
Make the answer very short. 1.23. What is the ratio of the Electricity production(% of total) in Serbia in 2007 to that in 2010?
Your response must be concise. 1.26. What is the ratio of the Electricity production(% of total) of Australia in 2007 to that in 2011?
Offer a very short reply. 0.67. What is the ratio of the Electricity production(% of total) in Hungary in 2007 to that in 2011?
Offer a very short reply. 1.28. What is the ratio of the Electricity production(% of total) in Serbia in 2007 to that in 2011?
Provide a succinct answer. 0.84. What is the ratio of the Electricity production(% of total) in Australia in 2008 to that in 2009?
Provide a short and direct response. 0.89. What is the ratio of the Electricity production(% of total) in Brunei Darussalam in 2008 to that in 2009?
Your answer should be very brief. 1. What is the ratio of the Electricity production(% of total) in Hungary in 2008 to that in 2009?
Your answer should be compact. 1.31. What is the ratio of the Electricity production(% of total) of Serbia in 2008 to that in 2009?
Your response must be concise. 2.46. What is the ratio of the Electricity production(% of total) in Australia in 2008 to that in 2010?
Your answer should be compact. 0.8. What is the ratio of the Electricity production(% of total) of Brunei Darussalam in 2008 to that in 2010?
Keep it short and to the point. 1. What is the ratio of the Electricity production(% of total) in Hungary in 2008 to that in 2010?
Provide a short and direct response. 1.22. What is the ratio of the Electricity production(% of total) of Serbia in 2008 to that in 2010?
Ensure brevity in your answer.  1.29. What is the ratio of the Electricity production(% of total) of Australia in 2008 to that in 2011?
Offer a terse response. 0.73. What is the ratio of the Electricity production(% of total) of Hungary in 2008 to that in 2011?
Keep it short and to the point. 1.27. What is the ratio of the Electricity production(% of total) of Serbia in 2008 to that in 2011?
Make the answer very short. 0.86. What is the ratio of the Electricity production(% of total) of Australia in 2009 to that in 2010?
Your answer should be very brief. 0.9. What is the ratio of the Electricity production(% of total) of Brunei Darussalam in 2009 to that in 2010?
Offer a very short reply. 1. What is the ratio of the Electricity production(% of total) in Hungary in 2009 to that in 2010?
Provide a short and direct response. 0.94. What is the ratio of the Electricity production(% of total) in Serbia in 2009 to that in 2010?
Keep it short and to the point. 0.52. What is the ratio of the Electricity production(% of total) of Australia in 2009 to that in 2011?
Your response must be concise. 0.82. What is the ratio of the Electricity production(% of total) in Hungary in 2009 to that in 2011?
Offer a terse response. 0.97. What is the ratio of the Electricity production(% of total) in Serbia in 2009 to that in 2011?
Ensure brevity in your answer.  0.35. What is the ratio of the Electricity production(% of total) in Australia in 2010 to that in 2011?
Your answer should be very brief. 0.91. What is the ratio of the Electricity production(% of total) in Brunei Darussalam in 2010 to that in 2011?
Give a very brief answer. 1. What is the ratio of the Electricity production(% of total) of Hungary in 2010 to that in 2011?
Your answer should be very brief. 1.04. What is the ratio of the Electricity production(% of total) of Serbia in 2010 to that in 2011?
Give a very brief answer. 0.66. What is the difference between the highest and the second highest Electricity production(% of total) in Australia?
Your response must be concise. 1.71. What is the difference between the highest and the second highest Electricity production(% of total) in Brunei Darussalam?
Provide a short and direct response. 0.05. What is the difference between the highest and the second highest Electricity production(% of total) in Hungary?
Your answer should be very brief. 0.2. What is the difference between the highest and the second highest Electricity production(% of total) of Serbia?
Offer a very short reply. 0.19. What is the difference between the highest and the lowest Electricity production(% of total) of Australia?
Offer a very short reply. 9.9. What is the difference between the highest and the lowest Electricity production(% of total) in Brunei Darussalam?
Offer a terse response. 0.16. What is the difference between the highest and the lowest Electricity production(% of total) of Hungary?
Make the answer very short. 9.09. 